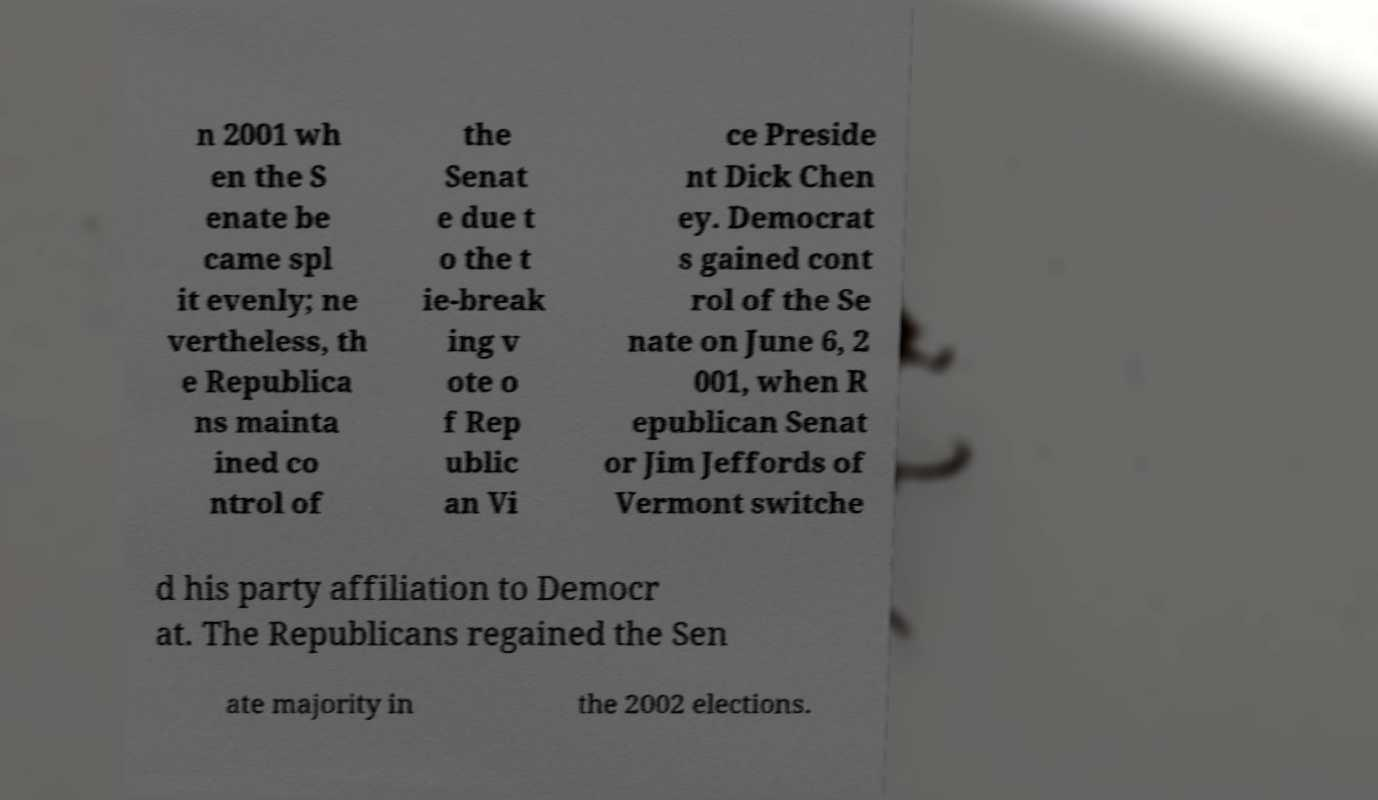Please identify and transcribe the text found in this image. n 2001 wh en the S enate be came spl it evenly; ne vertheless, th e Republica ns mainta ined co ntrol of the Senat e due t o the t ie-break ing v ote o f Rep ublic an Vi ce Preside nt Dick Chen ey. Democrat s gained cont rol of the Se nate on June 6, 2 001, when R epublican Senat or Jim Jeffords of Vermont switche d his party affiliation to Democr at. The Republicans regained the Sen ate majority in the 2002 elections. 